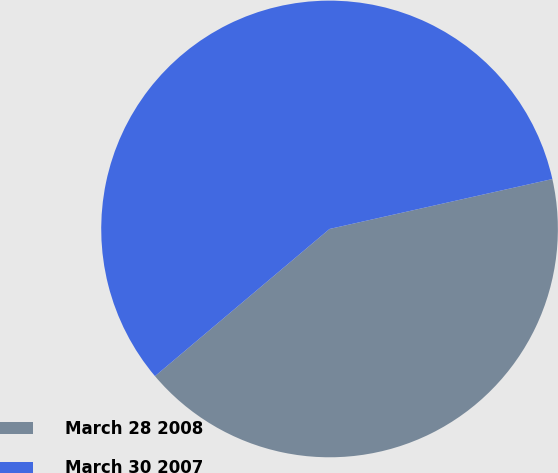Convert chart to OTSL. <chart><loc_0><loc_0><loc_500><loc_500><pie_chart><fcel>March 28 2008<fcel>March 30 2007<nl><fcel>42.36%<fcel>57.64%<nl></chart> 